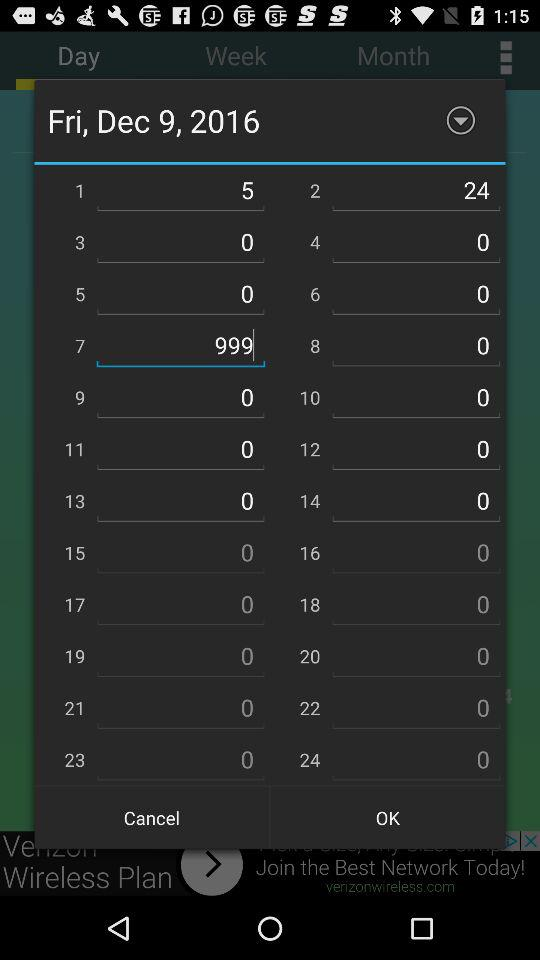What is the day and date? The day and date is Friday, Dec 9, 2016. 